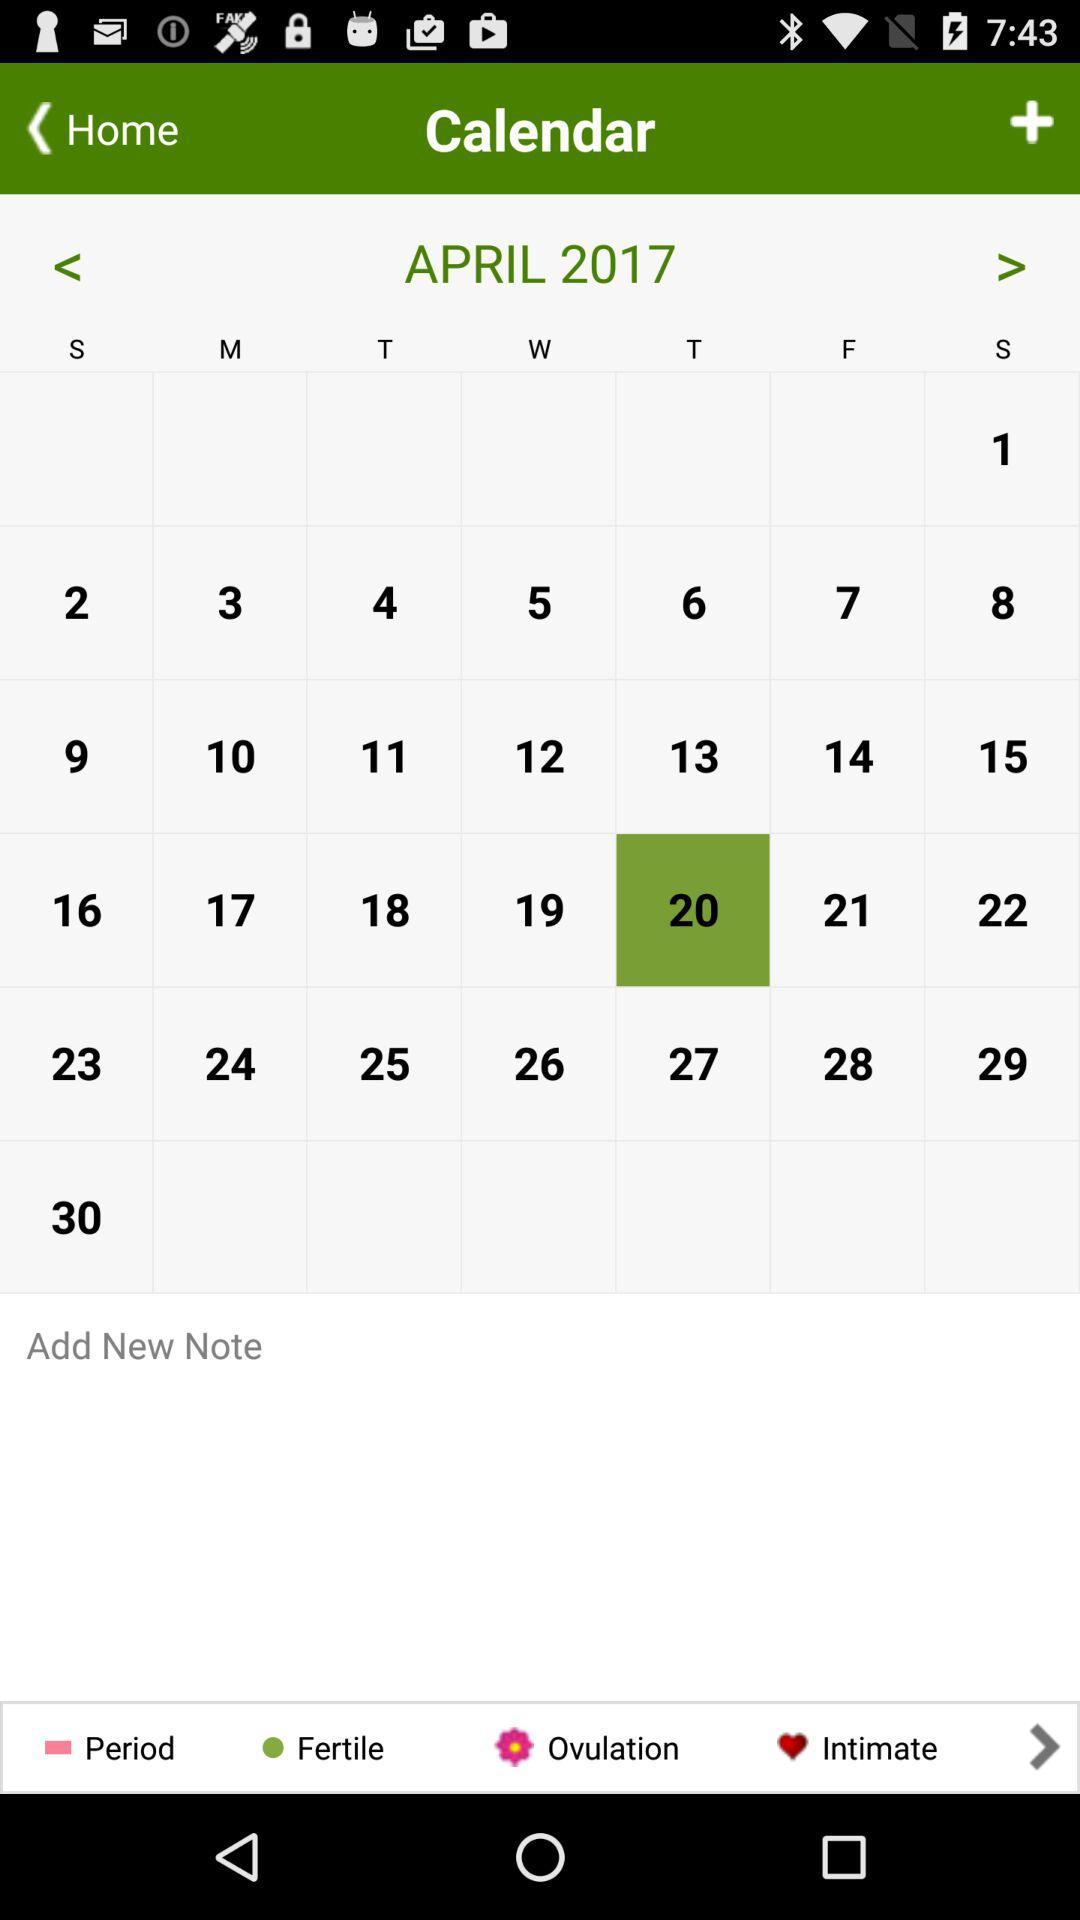What are the month and year? The month is April and the year is 2017. 